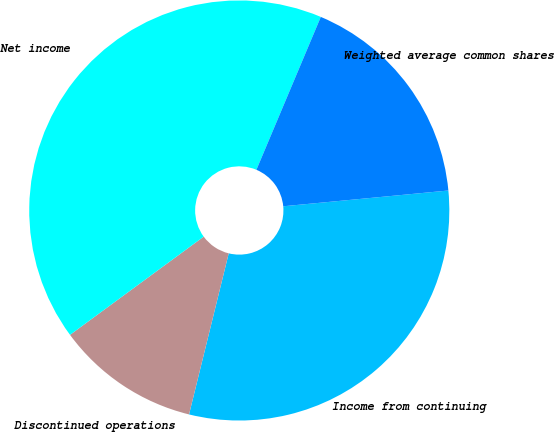Convert chart. <chart><loc_0><loc_0><loc_500><loc_500><pie_chart><fcel>Income from continuing<fcel>Discontinued operations<fcel>Net income<fcel>Weighted average common shares<nl><fcel>30.36%<fcel>11.07%<fcel>41.43%<fcel>17.14%<nl></chart> 